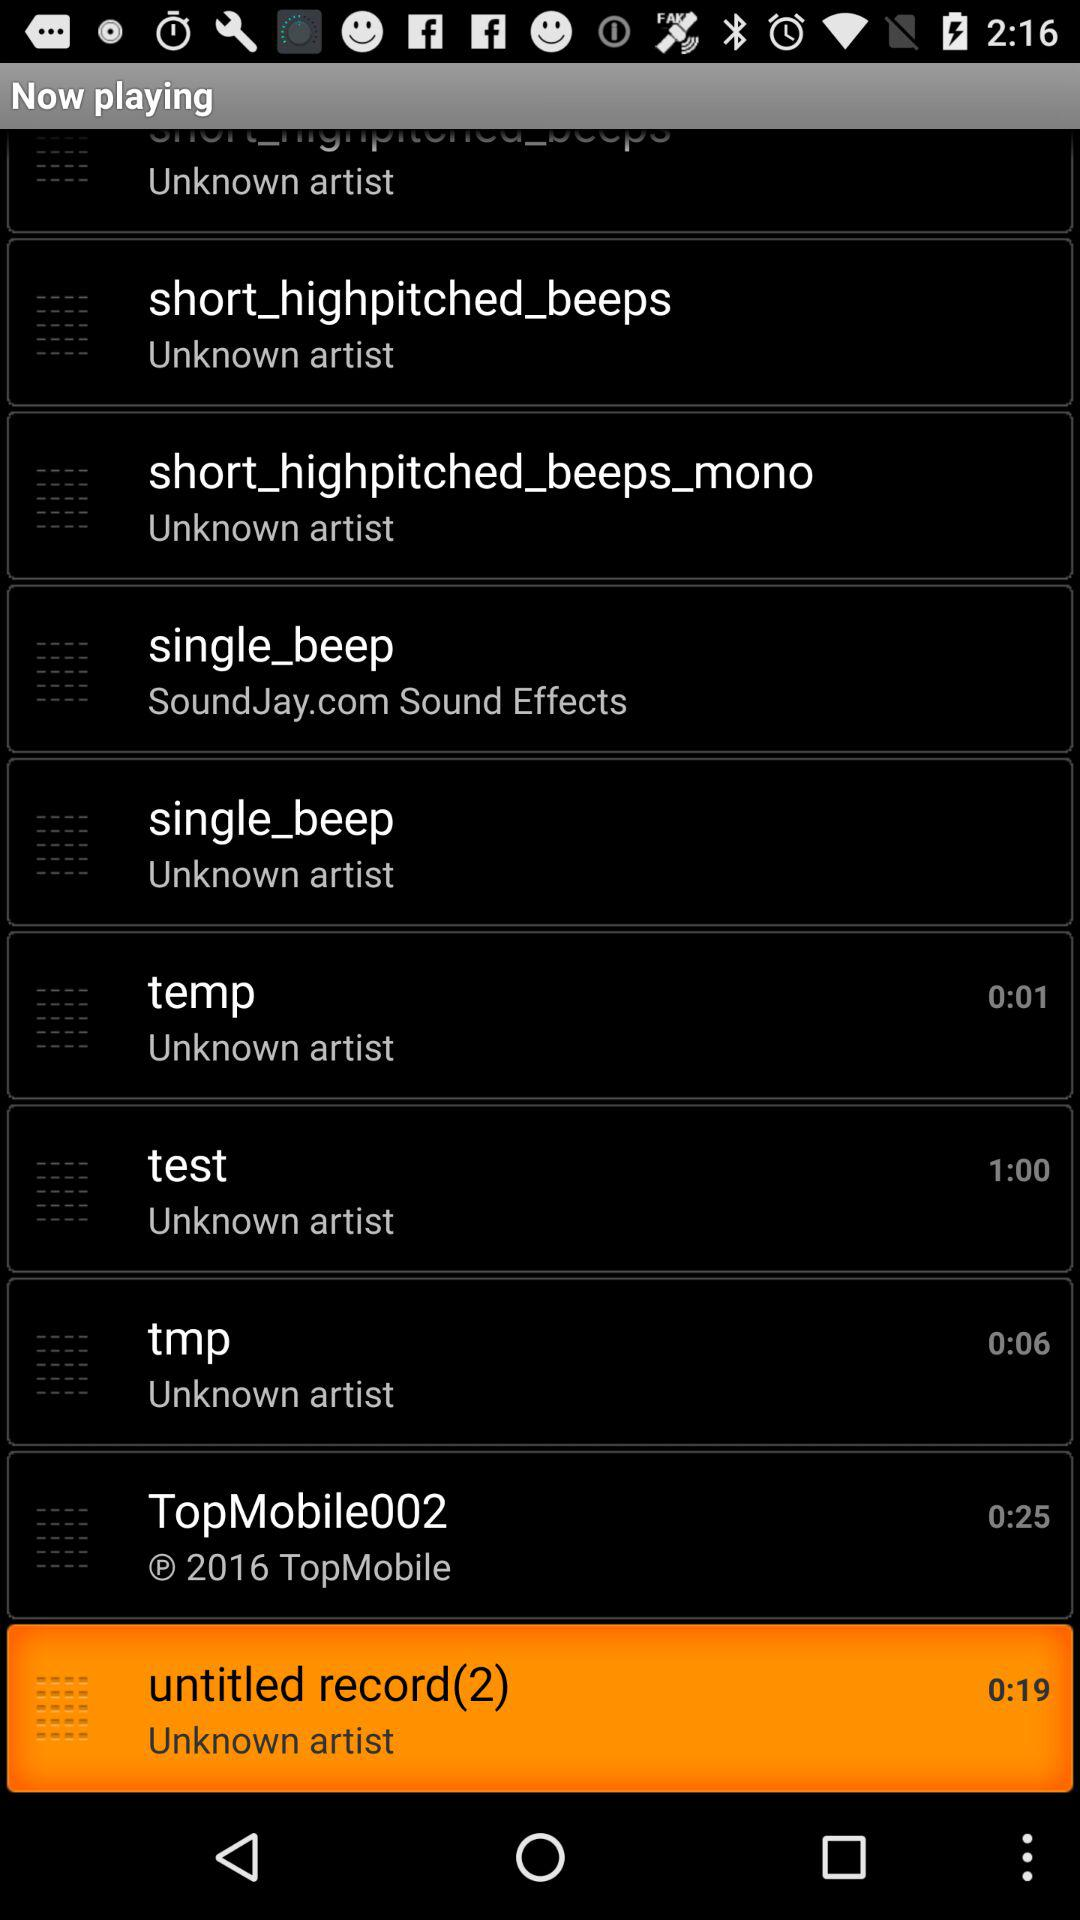Who is the artist of "temp" audio file? The artist is unknown. 